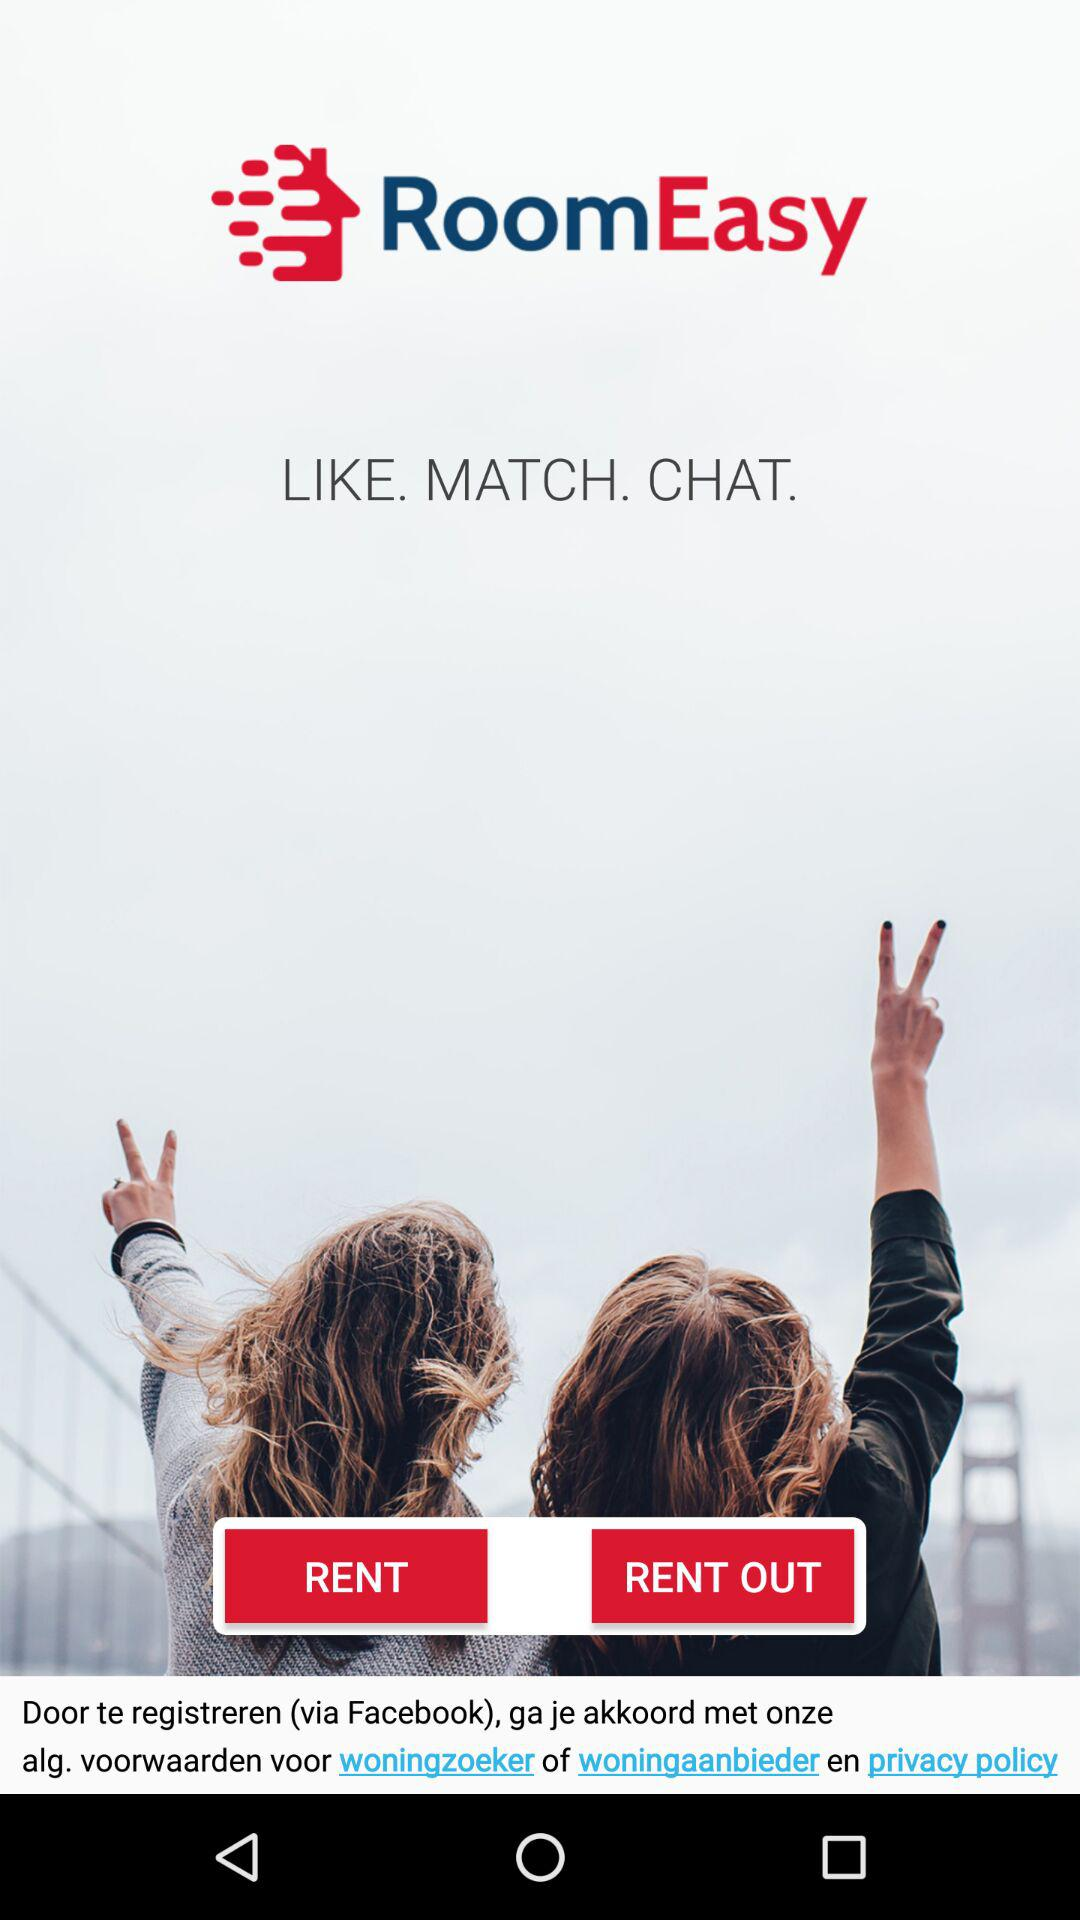How many matches are there?
When the provided information is insufficient, respond with <no answer>. <no answer> 